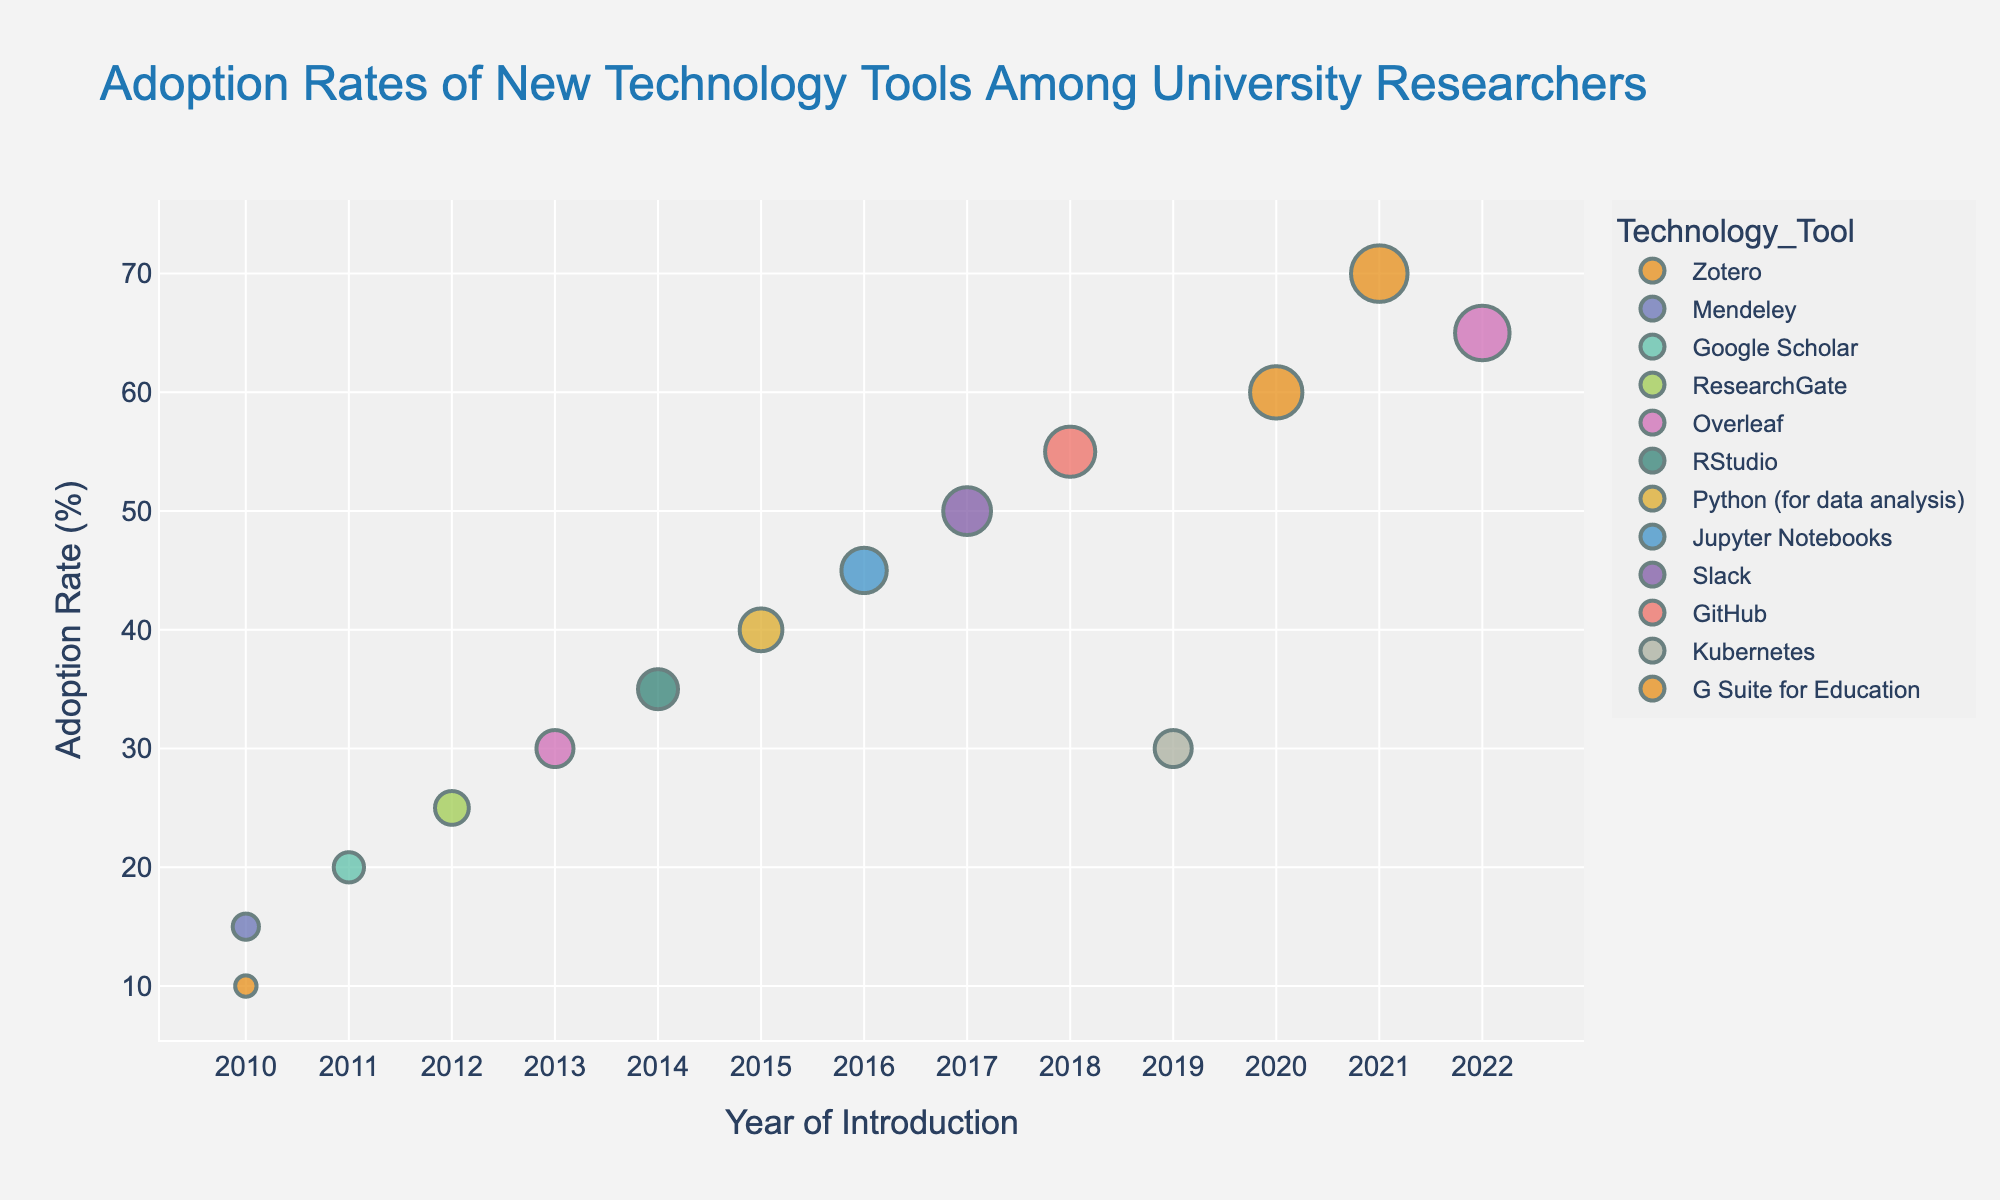What is the title of the figure? The title is displayed at the top of the figure, usually in larger and distinctive font. It reads "Adoption Rates of New Technology Tools Among University Researchers"
Answer: Adoption Rates of New Technology Tools Among University Researchers Which year had the highest adoption rate for a technology tool, and what was the tool? Look at the y-axis to identify the highest point, then trace it back to the corresponding x-axis and hover information to get the year and the tool. The highest adoption rate is 2020 for "G Suite for Education".
Answer: 2020, G Suite for Education Which tool introduced in 2015 had its adoption rate lower than any other tool in 2018? Compare the adoption rates of tools introduced in 2015 and 2018. In 2015, "Python (for data analysis)" had a 40% adoption rate, and in 2018, "GitHub" had a 55% adoption rate.
Answer: Python (for data analysis) How did the adoption rate of Zotero change from 2010 to 2021? Identify the data points for Zotero in 2010 and 2021 on the plot, and compare their y-axis values. The adoption rate for Zotero increased from 10% in 2010 to 70% in 2021.
Answer: Increased from 10% to 70% What is the average adoption rate of tools introduced in 2010? Identify the tools in 2010 and their adoption rates, then calculate the average. For Zotero (10%) and Mendeley (15%), the average is (10 + 15) / 2 = 12.5%.
Answer: 12.5% Which tool had the highest adoption rate increase between two consecutive points, and what was the increase? By comparing the adoption rates of each tool between the two years it appears, "Zotero" increased from 10% in 2010 to 70% in 2021, marking the highest increase of 60%.
Answer: Zotero, 60% Which year had the most diverse set of tools introduced (in terms of the number of tools)? Count the frequency of different tools per year by observing the data points clustered on the x-axis. The year 2010 had the highest number of tools (two tools: Zotero and Mendeley).
Answer: 2010 How many tools had an adoption rate of over 50%? Examine the y-axis values to count data points above 50%. Tools are: Slack (2017), GitHub (2018), G Suite for Education (2020), and Zotero (2021).
Answer: 4 